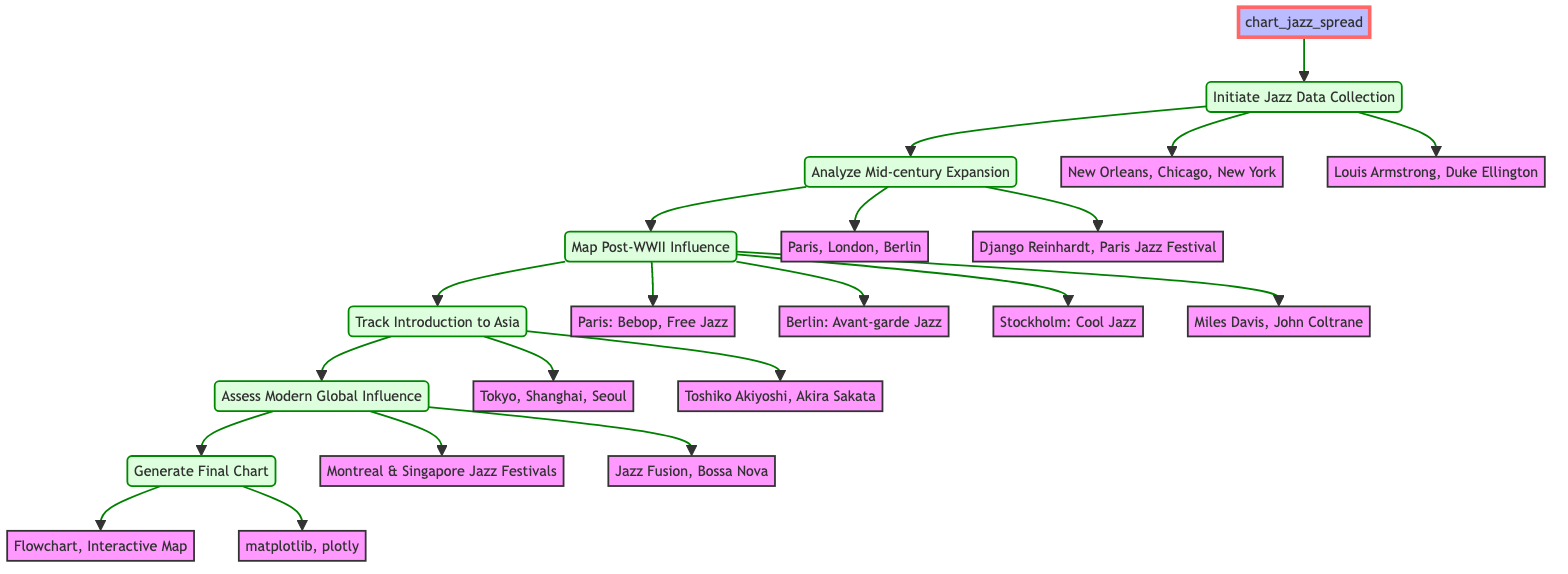What are the three collection points for jazz data? The diagram lists the collection points as New Orleans, Chicago, and New York, which are directly connected to the step "Initiate Jazz Data Collection".
Answer: New Orleans, Chicago, New York Who are the two key figures mentioned in the jazz data collection? The key figures in the data collection step are specified as Louis Armstrong and Duke Ellington, which are shown under "Initiate Jazz Data Collection".
Answer: Louis Armstrong, Duke Ellington What are the three European destinations analyzed during mid-century expansion? The diagram indicates that the European destinations during the "Analyze Mid-century Expansion" step include Paris, London, and Berlin, and are linked to that specific step.
Answer: Paris, London, Berlin Which trends in jazz are associated with Paris after WWII? For the "Map Post-WWII Influence" step, the trends associated with Paris are identified as Bebop and Free Jazz. These trends are directly connected to that portion of the diagram.
Answer: Bebop, Free Jazz What are the notable figures mentioned for Asia in the introduction step? The notable figures introduced to Asia, as reflected in the diagram under the "Track Introduction to Asia" step, are Toshiko Akiyoshi and Akira Sakata.
Answer: Toshiko Akiyoshi, Akira Sakata How many festivals are listed under modern global influence? In the "Assess Modern Global Influence" step, there are two jazz festivals mentioned: Montreal International Jazz Festival and Singapore Jazz Festival, directly indicating the count.
Answer: 2 What is generated as the final output of the function? According to the last step "Generate Final Chart", the outputs listed are a flowchart and an interactive map. Therefore, the final output refers to these two formats.
Answer: Flowchart, Interactive Map Which tools are specified for generating the final chart? The diagram outlines the tools as matplotlib and plotly under the "Generate Final Chart" step, representing the resources utilized in this process.
Answer: matplotlib, plotly What is the relationship between the step 'Initiate Jazz Data Collection' and 'Analyze Mid-century Expansion'? The diagram shows a direct connection from the "Initiate Jazz Data Collection" step to the "Analyze Mid-century Expansion" step, indicating that the analysis follows the data collection process.
Answer: Direct connection 